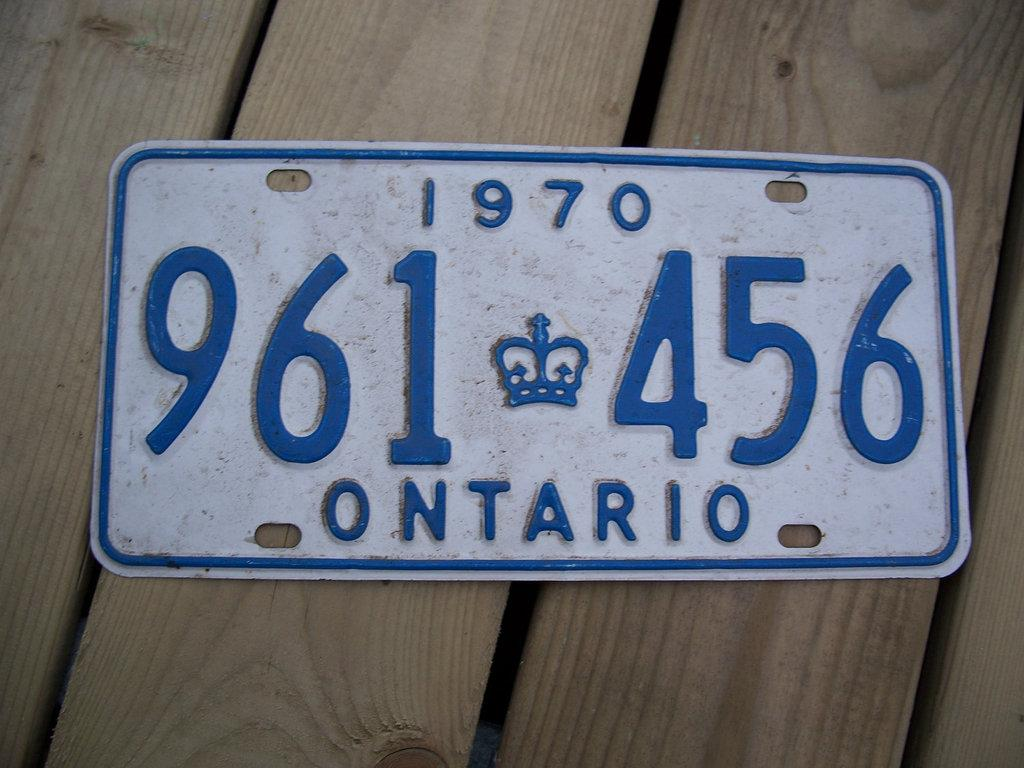<image>
Create a compact narrative representing the image presented. A white license plate says Ontario in blue letters and is on a wooden table. 